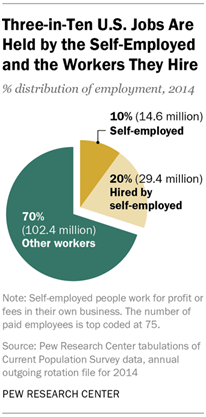Draw attention to some important aspects in this diagram. The pie chart has only three segments. Yes. The percentage distribution of Other workers is greater than the sum of Self-employed and Hired by self-employed workers. 